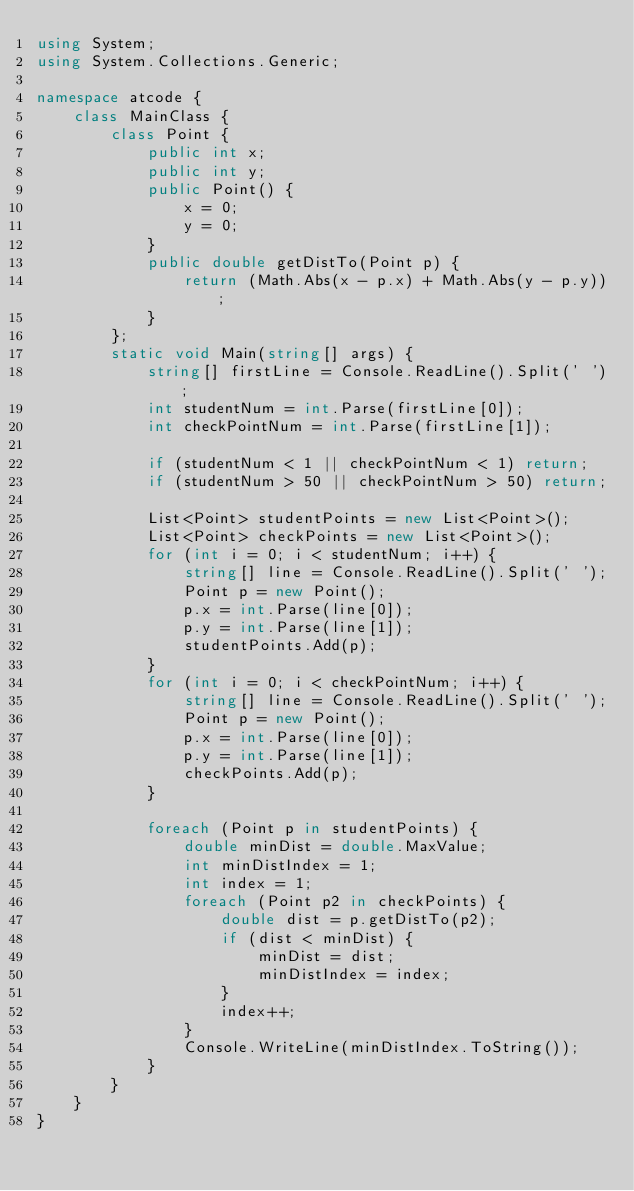<code> <loc_0><loc_0><loc_500><loc_500><_C#_>using System;
using System.Collections.Generic;

namespace atcode {
    class MainClass {
        class Point {
            public int x;
            public int y;
            public Point() {
                x = 0;
                y = 0;
            }
            public double getDistTo(Point p) {
                return (Math.Abs(x - p.x) + Math.Abs(y - p.y));
            }
        };
		static void Main(string[] args) {
            string[] firstLine = Console.ReadLine().Split(' ');
            int studentNum = int.Parse(firstLine[0]);
            int checkPointNum = int.Parse(firstLine[1]);

            if (studentNum < 1 || checkPointNum < 1) return;
            if (studentNum > 50 || checkPointNum > 50) return;

            List<Point> studentPoints = new List<Point>();
            List<Point> checkPoints = new List<Point>();
            for (int i = 0; i < studentNum; i++) {
                string[] line = Console.ReadLine().Split(' ');
                Point p = new Point();
                p.x = int.Parse(line[0]);
                p.y = int.Parse(line[1]);
                studentPoints.Add(p);
            }
			for (int i = 0; i < checkPointNum; i++) {
                string[] line = Console.ReadLine().Split(' ');
				Point p = new Point();
                p.x = int.Parse(line[0]);
                p.y = int.Parse(line[1]);
                checkPoints.Add(p);
            }

            foreach (Point p in studentPoints) {
                double minDist = double.MaxValue;
                int minDistIndex = 1;
                int index = 1;
                foreach (Point p2 in checkPoints) {
                    double dist = p.getDistTo(p2);
                    if (dist < minDist) {
                        minDist = dist;
                        minDistIndex = index;
                    }
                    index++;
                }
				Console.WriteLine(minDistIndex.ToString());
            }
		}
    }
}
</code> 